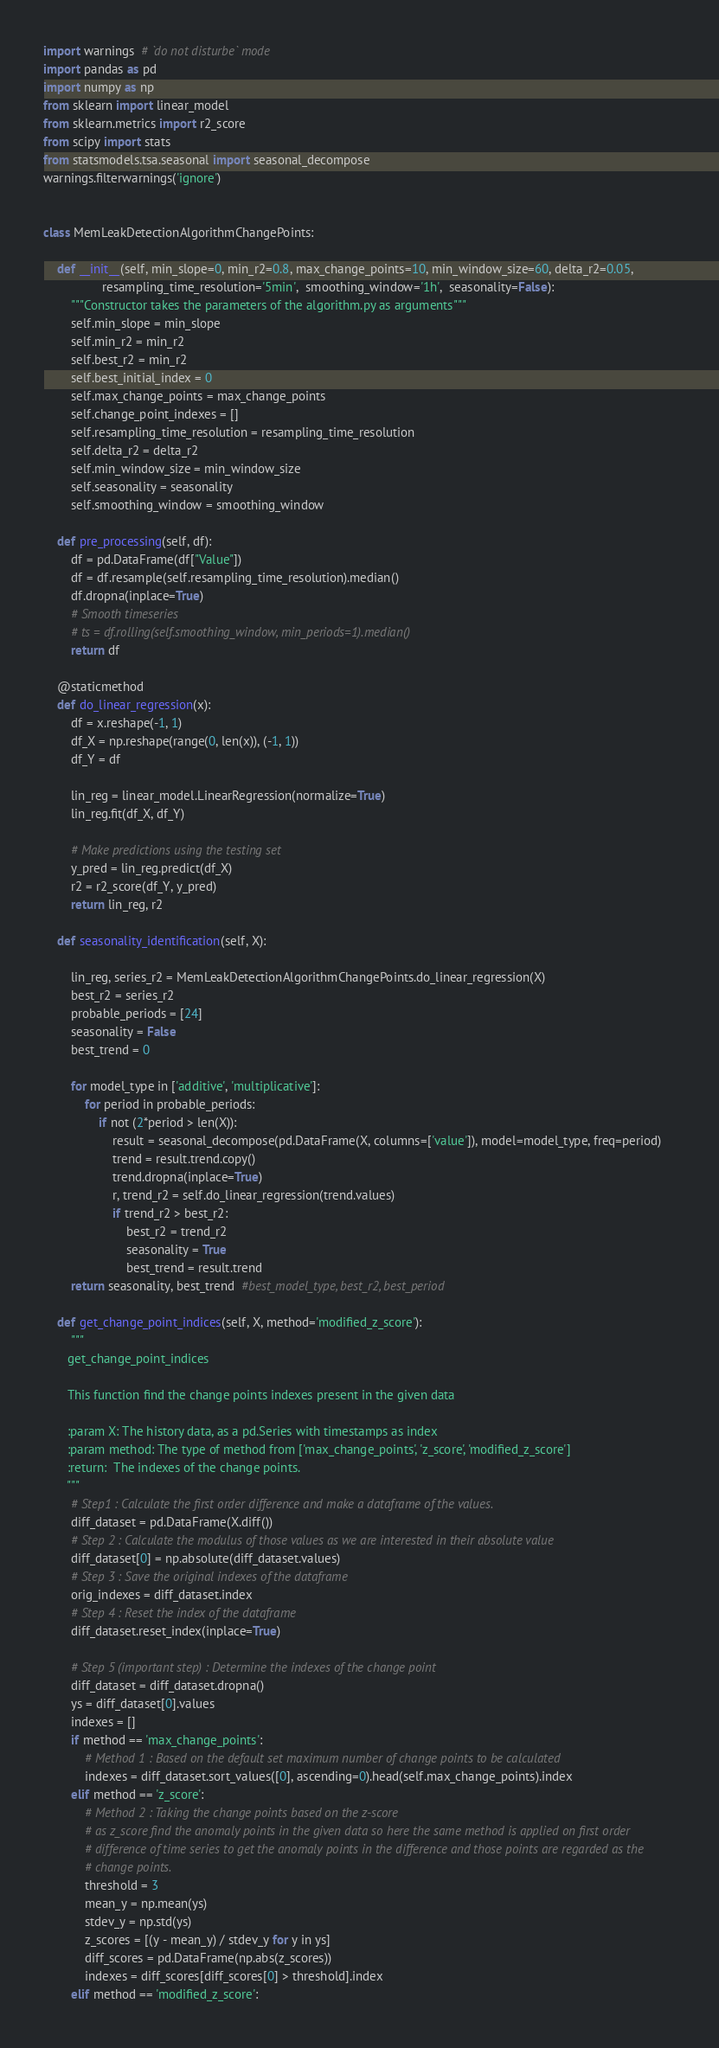<code> <loc_0><loc_0><loc_500><loc_500><_Python_>import warnings  # `do not disturbe` mode
import pandas as pd
import numpy as np
from sklearn import linear_model
from sklearn.metrics import r2_score
from scipy import stats
from statsmodels.tsa.seasonal import seasonal_decompose
warnings.filterwarnings('ignore')


class MemLeakDetectionAlgorithmChangePoints:

    def __init__(self, min_slope=0, min_r2=0.8, max_change_points=10, min_window_size=60, delta_r2=0.05,
                 resampling_time_resolution='5min',  smoothing_window='1h',  seasonality=False):
        """Constructor takes the parameters of the algorithm.py as arguments"""
        self.min_slope = min_slope
        self.min_r2 = min_r2
        self.best_r2 = min_r2
        self.best_initial_index = 0
        self.max_change_points = max_change_points
        self.change_point_indexes = []
        self.resampling_time_resolution = resampling_time_resolution
        self.delta_r2 = delta_r2
        self.min_window_size = min_window_size
        self.seasonality = seasonality
        self.smoothing_window = smoothing_window

    def pre_processing(self, df):
        df = pd.DataFrame(df["Value"])
        df = df.resample(self.resampling_time_resolution).median()
        df.dropna(inplace=True)
        # Smooth timeseries
        # ts = df.rolling(self.smoothing_window, min_periods=1).median()
        return df

    @staticmethod
    def do_linear_regression(x):
        df = x.reshape(-1, 1)
        df_X = np.reshape(range(0, len(x)), (-1, 1))
        df_Y = df

        lin_reg = linear_model.LinearRegression(normalize=True)
        lin_reg.fit(df_X, df_Y)

        # Make predictions using the testing set
        y_pred = lin_reg.predict(df_X)
        r2 = r2_score(df_Y, y_pred)
        return lin_reg, r2

    def seasonality_identification(self, X):

        lin_reg, series_r2 = MemLeakDetectionAlgorithmChangePoints.do_linear_regression(X)
        best_r2 = series_r2
        probable_periods = [24]
        seasonality = False
        best_trend = 0

        for model_type in ['additive', 'multiplicative']:
            for period in probable_periods:
                if not (2*period > len(X)):
                    result = seasonal_decompose(pd.DataFrame(X, columns=['value']), model=model_type, freq=period)
                    trend = result.trend.copy()
                    trend.dropna(inplace=True)
                    r, trend_r2 = self.do_linear_regression(trend.values)
                    if trend_r2 > best_r2:
                        best_r2 = trend_r2
                        seasonality = True
                        best_trend = result.trend
        return seasonality, best_trend  #best_model_type, best_r2, best_period

    def get_change_point_indices(self, X, method='modified_z_score'):
        """
       get_change_point_indices

       This function find the change points indexes present in the given data

       :param X: The history data, as a pd.Series with timestamps as index
       :param method: The type of method from ['max_change_points', 'z_score', 'modified_z_score']
       :return:  The indexes of the change points.
       """
        # Step1 : Calculate the first order difference and make a dataframe of the values.
        diff_dataset = pd.DataFrame(X.diff())
        # Step 2 : Calculate the modulus of those values as we are interested in their absolute value
        diff_dataset[0] = np.absolute(diff_dataset.values)
        # Step 3 : Save the original indexes of the dataframe
        orig_indexes = diff_dataset.index
        # Step 4 : Reset the index of the dataframe
        diff_dataset.reset_index(inplace=True)

        # Step 5 (important step) : Determine the indexes of the change point
        diff_dataset = diff_dataset.dropna()
        ys = diff_dataset[0].values
        indexes = []
        if method == 'max_change_points':
            # Method 1 : Based on the default set maximum number of change points to be calculated
            indexes = diff_dataset.sort_values([0], ascending=0).head(self.max_change_points).index
        elif method == 'z_score':
            # Method 2 : Taking the change points based on the z-score
            # as z_score find the anomaly points in the given data so here the same method is applied on first order
            # difference of time series to get the anomaly points in the difference and those points are regarded as the
            # change points.
            threshold = 3
            mean_y = np.mean(ys)
            stdev_y = np.std(ys)
            z_scores = [(y - mean_y) / stdev_y for y in ys]
            diff_scores = pd.DataFrame(np.abs(z_scores))
            indexes = diff_scores[diff_scores[0] > threshold].index
        elif method == 'modified_z_score':</code> 